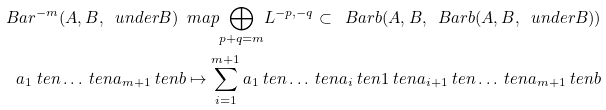<formula> <loc_0><loc_0><loc_500><loc_500>\ B a r ^ { - m } ( A , B , \ u n d e r B ) \ m a p \underset { p + q = m } { \bigoplus } L ^ { - p , - q } \subset \ B a r b ( A , B , \ B a r b ( A , B , \ u n d e r B ) ) \\ a _ { 1 } \ t e n \dots \ t e n a _ { m + 1 } \ t e n b \mapsto \sum _ { i = 1 } ^ { m + 1 } a _ { 1 } \ t e n \dots \ t e n a _ { i } \ t e n 1 \ t e n a _ { i + 1 } \ t e n \dots \ t e n a _ { m + 1 } \ t e n b</formula> 